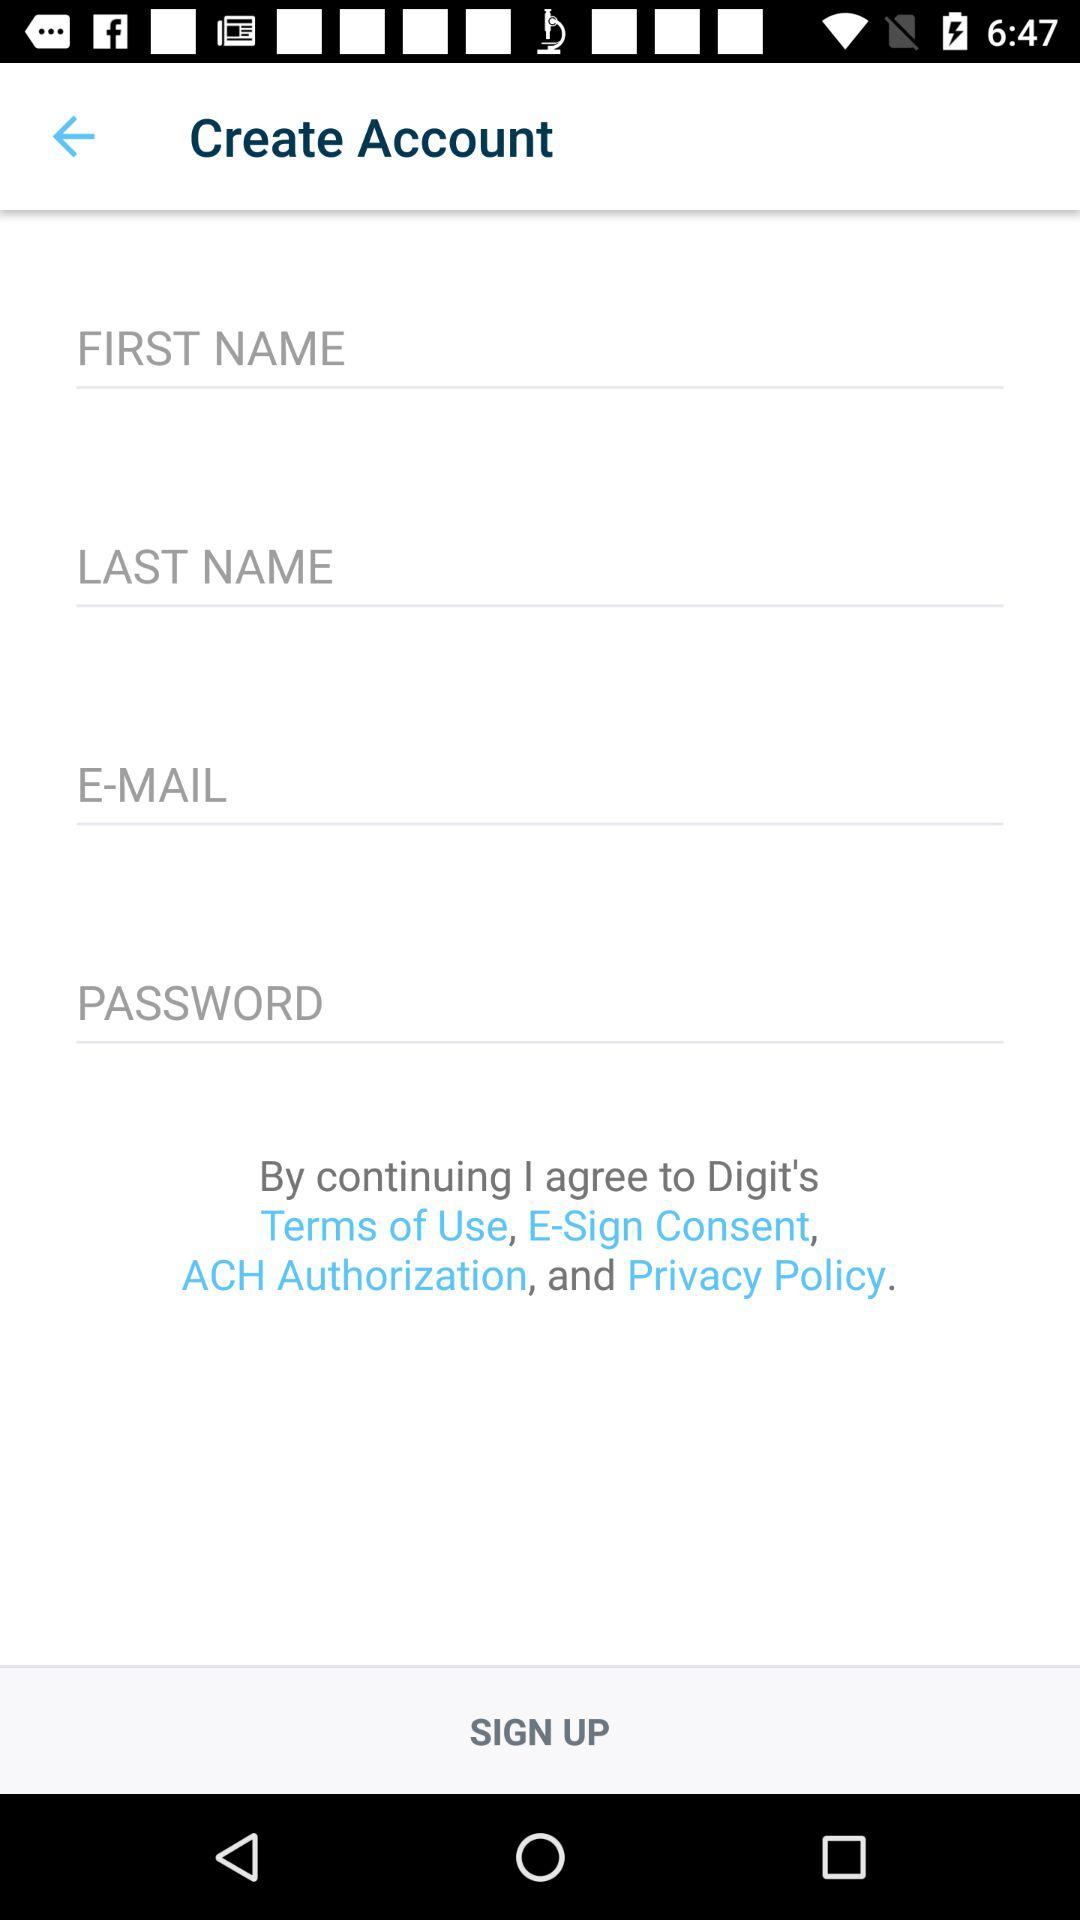How many text fields are there in the account creation form?
Answer the question using a single word or phrase. 4 